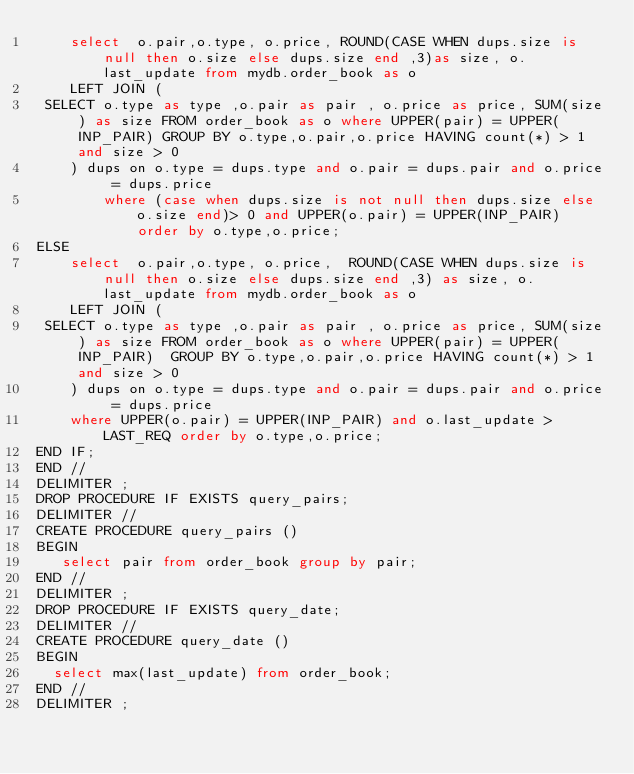Convert code to text. <code><loc_0><loc_0><loc_500><loc_500><_SQL_>    select  o.pair,o.type, o.price, ROUND(CASE WHEN dups.size is null then o.size else dups.size end ,3)as size, o.last_update from mydb.order_book as o 
    LEFT JOIN (
 SELECT o.type as type ,o.pair as pair , o.price as price, SUM(size) as size FROM order_book as o where UPPER(pair) = UPPER(INP_PAIR) GROUP BY o.type,o.pair,o.price HAVING count(*) > 1 and size > 0
		) dups on o.type = dups.type and o.pair = dups.pair and o.price = dups.price 
        where (case when dups.size is not null then dups.size else o.size end)> 0 and UPPER(o.pair) = UPPER(INP_PAIR)  order by o.type,o.price;
ELSE
    select  o.pair,o.type, o.price,  ROUND(CASE WHEN dups.size is null then o.size else dups.size end ,3) as size, o.last_update from mydb.order_book as o 
    LEFT JOIN (
 SELECT o.type as type ,o.pair as pair , o.price as price, SUM(size) as size FROM order_book as o where UPPER(pair) = UPPER(INP_PAIR)  GROUP BY o.type,o.pair,o.price HAVING count(*) > 1 and size > 0
		) dups on o.type = dups.type and o.pair = dups.pair and o.price = dups.price
    where UPPER(o.pair) = UPPER(INP_PAIR) and o.last_update > LAST_REQ order by o.type,o.price;
END IF;
END //
DELIMITER ;
DROP PROCEDURE IF EXISTS query_pairs;
DELIMITER //
CREATE PROCEDURE query_pairs () 
BEGIN
	 select pair from order_book group by pair;
END //
DELIMITER ;
DROP PROCEDURE IF EXISTS query_date;
DELIMITER //
CREATE PROCEDURE query_date ()
BEGIN
	select max(last_update) from order_book;
END //
DELIMITER ; 






</code> 